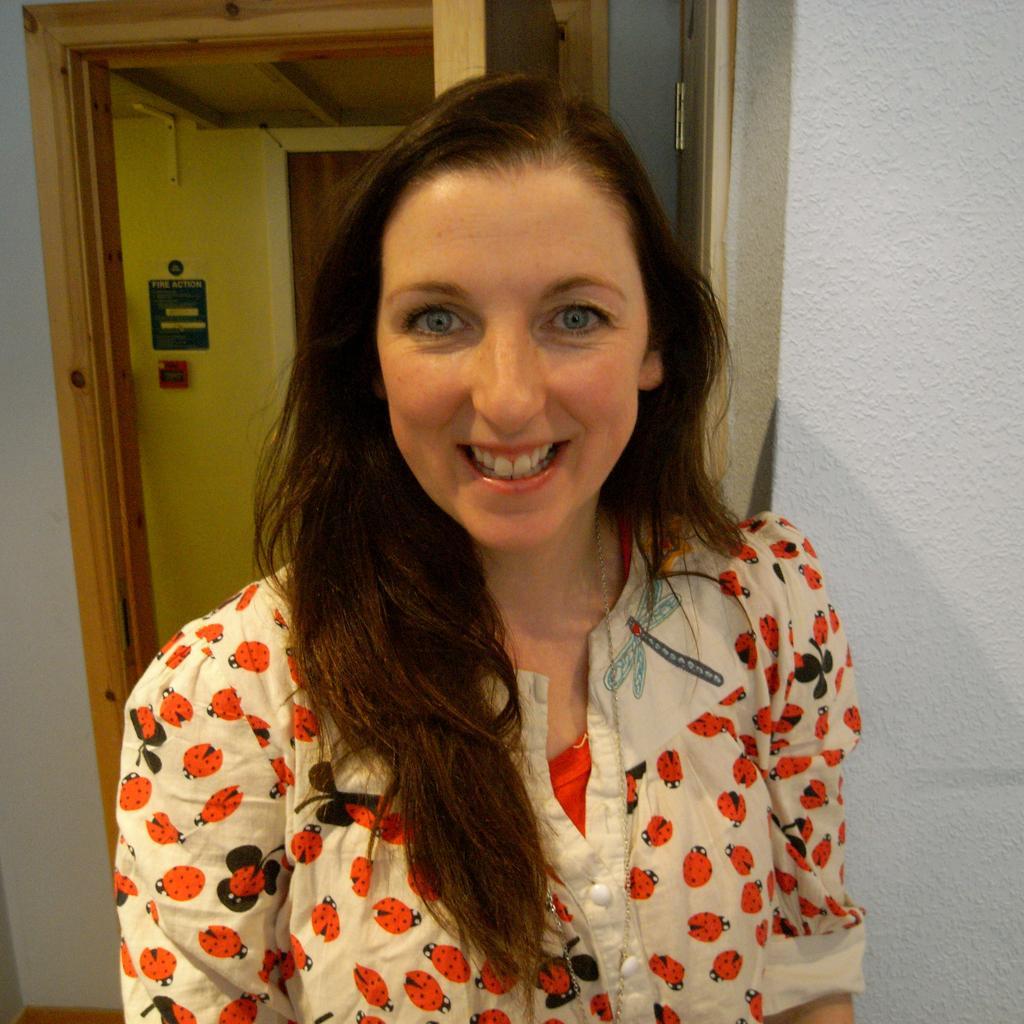Can you describe this image briefly? In this image there is a woman in the middle. In the background there is a door near the wall. On the wall there is a fire alarm. 